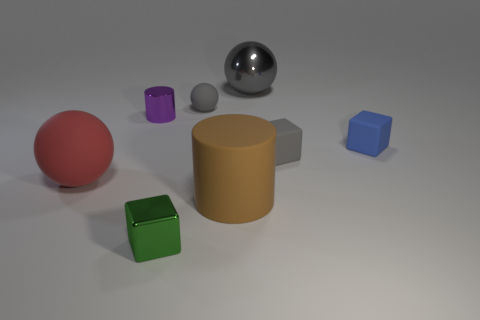The block on the left side of the gray metallic ball is what color?
Your response must be concise. Green. Are there fewer small green metallic objects behind the tiny gray rubber sphere than small matte objects?
Offer a terse response. Yes. There is a rubber cube that is the same color as the tiny ball; what is its size?
Provide a succinct answer. Small. Are there any other things that are the same size as the rubber cylinder?
Your answer should be compact. Yes. Is the small blue thing made of the same material as the large brown thing?
Your response must be concise. Yes. What number of objects are large things that are right of the tiny gray ball or matte spheres that are right of the big red thing?
Your answer should be very brief. 3. Are there any other gray shiny cylinders that have the same size as the shiny cylinder?
Your answer should be compact. No. There is another thing that is the same shape as the brown rubber thing; what is its color?
Give a very brief answer. Purple. There is a cylinder that is in front of the small blue cube; are there any red rubber things to the right of it?
Offer a terse response. No. Do the metallic object behind the small shiny cylinder and the small blue matte thing have the same shape?
Your answer should be very brief. No. 